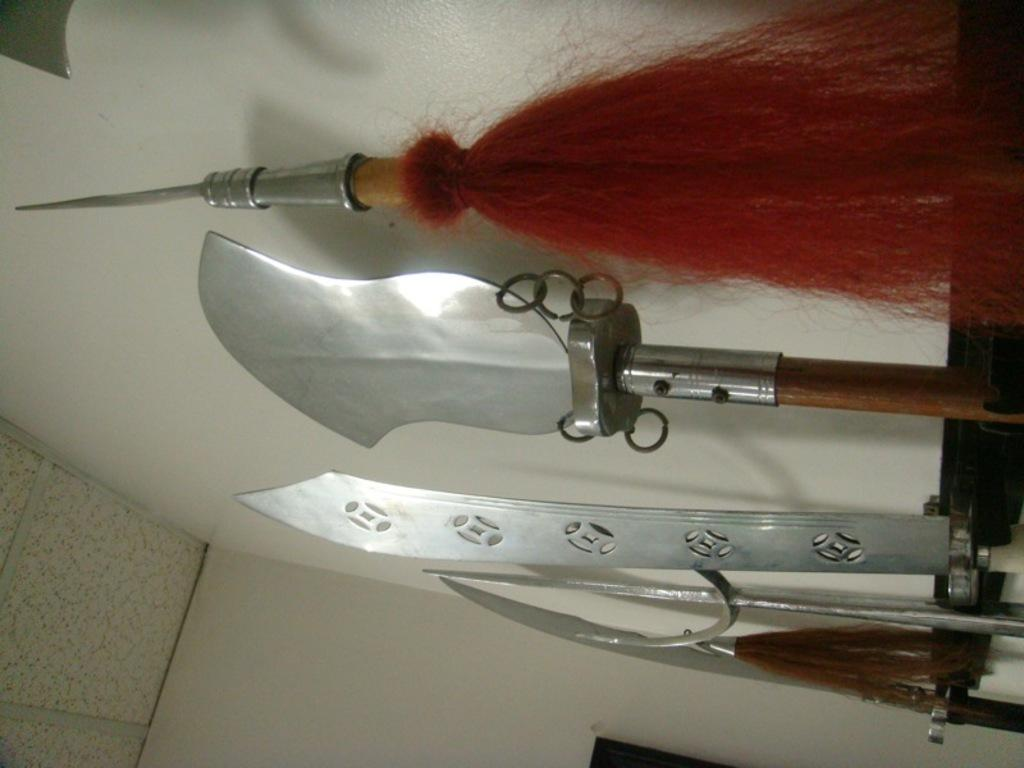What type of objects can be seen in the image? There are steel objects in the image. What is visible in the background of the image? The background of the image includes a white wall. What type of plantation is visible in the image? There is no plantation present in the image; it only features steel objects and a white wall in the background. 